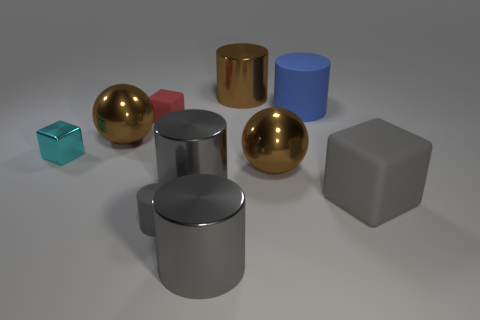There is a brown sphere behind the cyan shiny block; is its size the same as the shiny cube?
Provide a short and direct response. No. How big is the thing that is on the right side of the gray rubber cylinder and in front of the big matte block?
Offer a very short reply. Large. How many matte things have the same size as the gray rubber cube?
Offer a very short reply. 1. How many matte cylinders are left of the large object in front of the large matte block?
Your answer should be very brief. 1. Do the object on the right side of the blue thing and the small cylinder have the same color?
Offer a terse response. Yes. There is a matte block on the left side of the large object that is behind the blue thing; are there any small matte blocks behind it?
Your answer should be compact. No. There is a shiny thing that is on the right side of the tiny metallic block and left of the tiny gray thing; what shape is it?
Your answer should be very brief. Sphere. Is there a large sphere of the same color as the metal cube?
Your answer should be compact. No. What is the color of the matte cylinder to the right of the metallic object behind the big blue matte object?
Offer a terse response. Blue. What is the size of the sphere to the right of the brown metal thing that is behind the tiny rubber thing that is behind the tiny gray rubber thing?
Give a very brief answer. Large. 